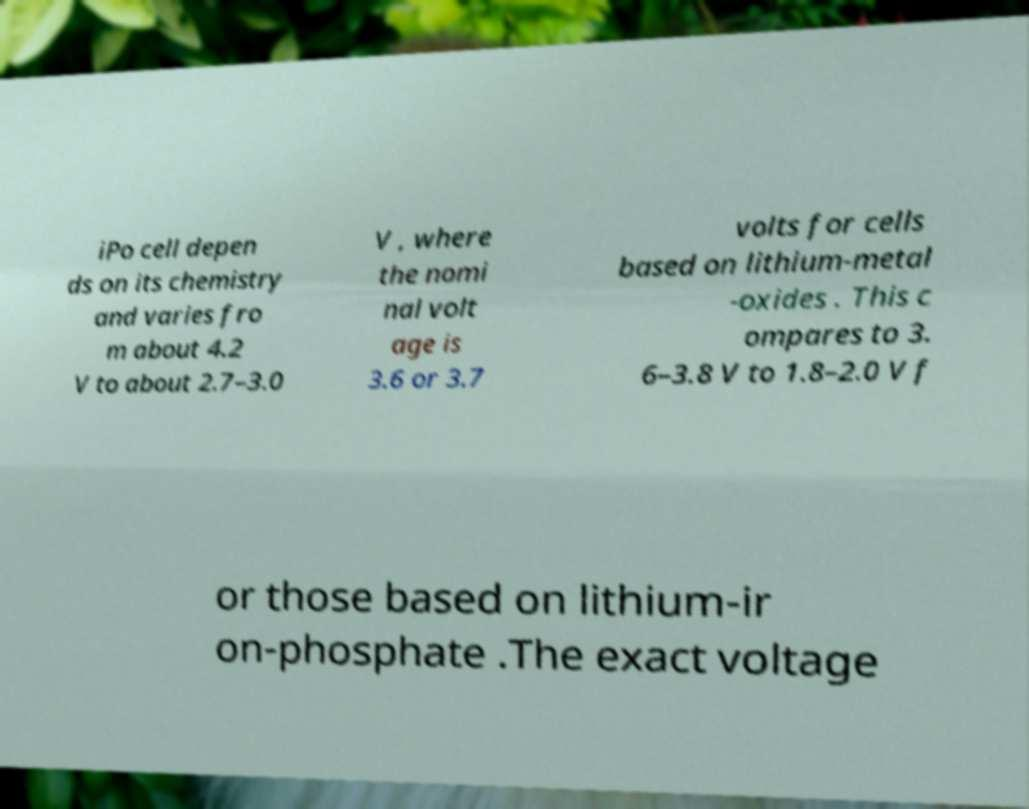Please identify and transcribe the text found in this image. iPo cell depen ds on its chemistry and varies fro m about 4.2 V to about 2.7–3.0 V , where the nomi nal volt age is 3.6 or 3.7 volts for cells based on lithium-metal -oxides . This c ompares to 3. 6–3.8 V to 1.8–2.0 V f or those based on lithium-ir on-phosphate .The exact voltage 